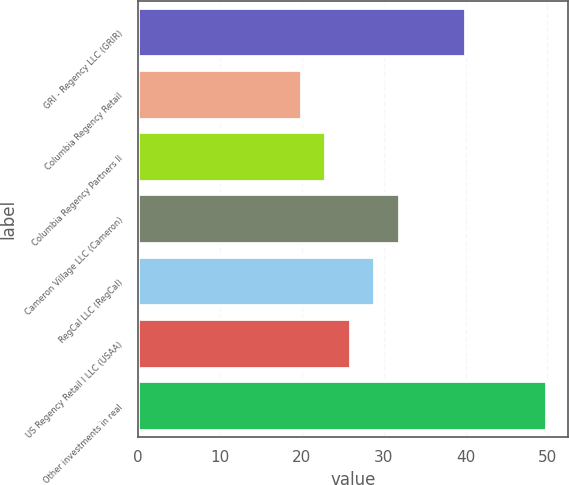Convert chart to OTSL. <chart><loc_0><loc_0><loc_500><loc_500><bar_chart><fcel>GRI - Regency LLC (GRIR)<fcel>Columbia Regency Retail<fcel>Columbia Regency Partners II<fcel>Cameron Village LLC (Cameron)<fcel>RegCal LLC (RegCal)<fcel>US Regency Retail I LLC (USAA)<fcel>Other investments in real<nl><fcel>40<fcel>20<fcel>23<fcel>32<fcel>29<fcel>26<fcel>50<nl></chart> 